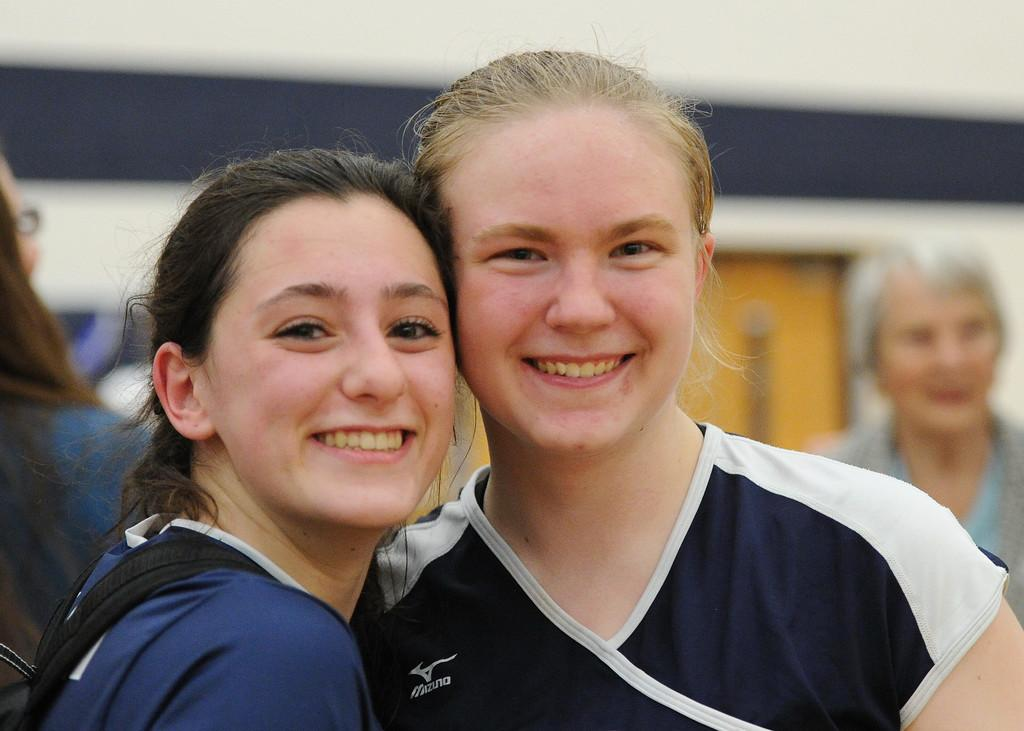How many women are in the foreground of the image? There are two women in the foreground of the image. What can be seen in the background of the image? In the background, people are visible. Can you describe any specific features in the background? There is a door visible in the background of the image. What type of slope can be seen in the image? There is no slope present in the image. 